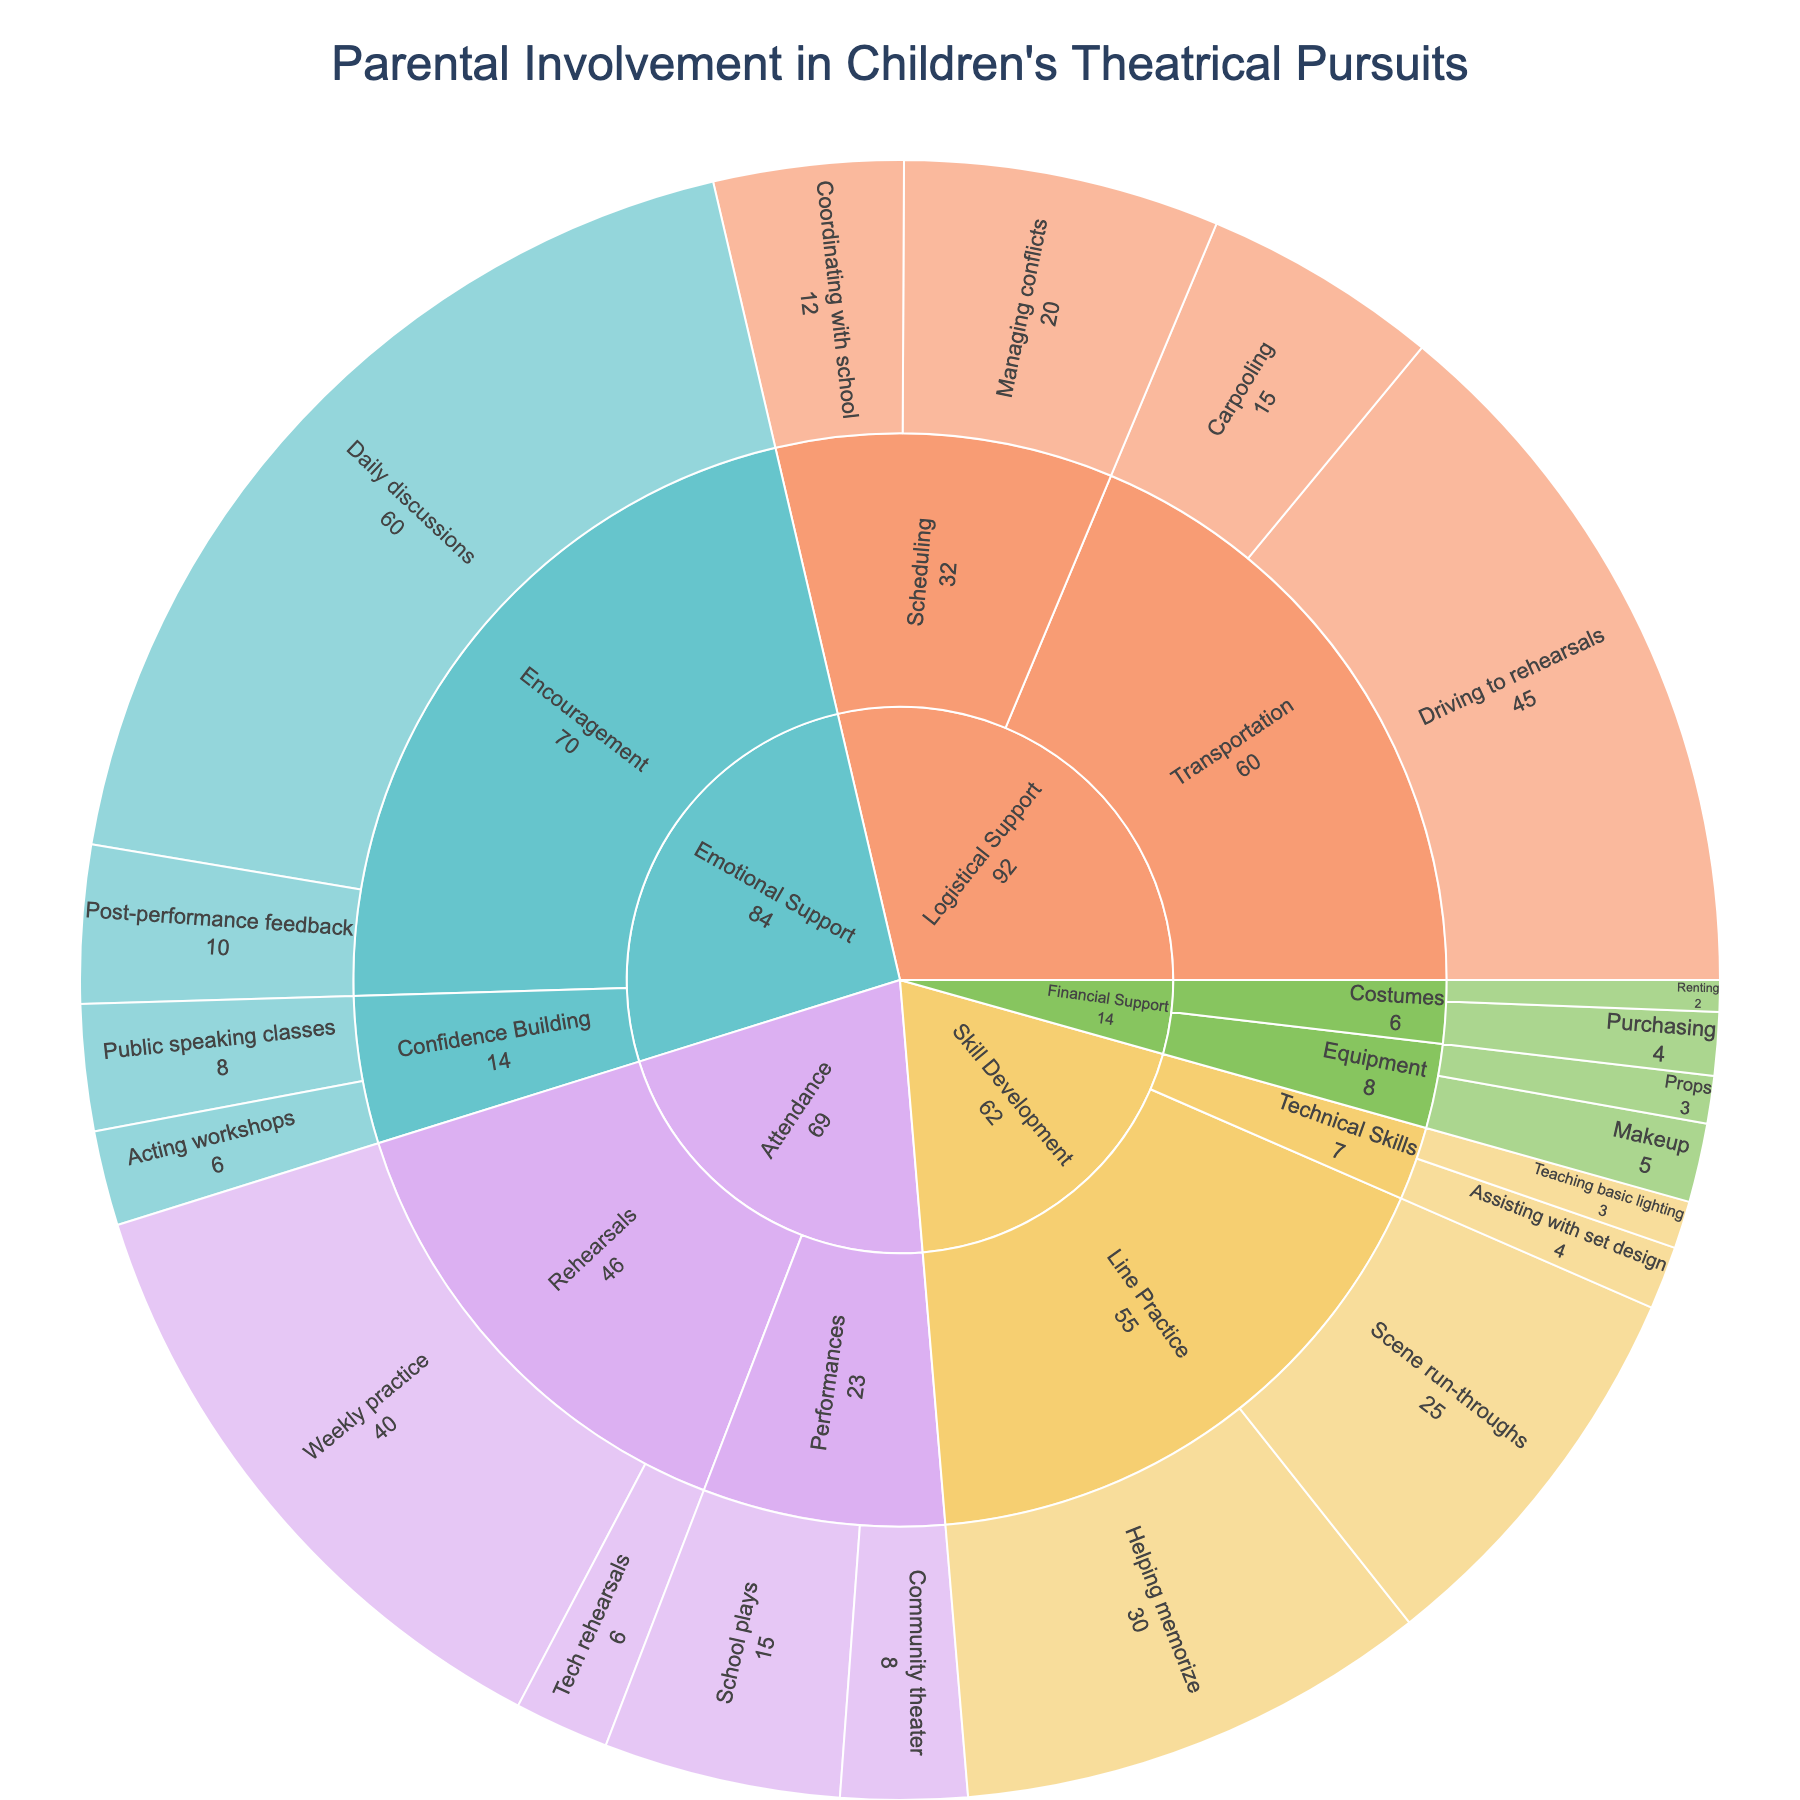What is the title of the figure? The title is typically placed at the top of the figure and provides a summary of what the plot represents. In this case, the title directly tells us about the primary focus of the plot.
Answer: Parental Involvement in Children's Theatrical Pursuits What category has the highest frequency of involvement? By looking at the largest segments in the sunburst plot, we can identify the category with the highest cumulative frequency.
Answer: Emotional Support Under Logistical Support, which subcategory has a higher frequency, Transportation or Scheduling? Locate the Logistical Support category, then compare the sizes of the segments for Transportation and Scheduling. The segment with the larger size has the higher frequency.
Answer: Transportation Which type of support is provided more frequently: Encouragement or Line Practice? First, identify the Emotional Support and Skill Development categories. Then, locate the Encouragement subcategory under Emotional Support and the Line Practice subcategory under Skill Development. Compare their segment sizes or numerical values.
Answer: Encouragement What is the total frequency for the Financial Support category? Sum the frequencies of all subcategories and types under Financial Support. This includes Costumes and Equipment with their respective types.
Answer: 14 How does the frequency of Daily discussions under Encouragement compare to Weekly practice under Rehearsals? Locate Daily discussions under Encouragement and Weekly practice under Rehearsals. Compare their frequencies.
Answer: Daily discussions has a higher frequency Which type within the Attendance category has the lowest frequency? Identify the subcategories under Attendance, then compare the frequencies of their types to determine the one with the lowest frequency.
Answer: Tech rehearsals How frequently do parents provide transportation to rehearsals? Locate the Transportation subcategory under Logistical Support and identify the frequency given for Driving to rehearsals.
Answer: 45 Calculate the total frequency of all types under Skill Development. Sum the frequencies of Helping memorize, Scene run-throughs, Assisting with set design, and Teaching basic lighting under the Skill Development category.
Answer: 62 Compare the frequencies of Purchasing and Renting costumes. Which one is higher? Locate the Costumes subcategory under Financial Support and compare the frequencies of Purchasing and Renting.
Answer: Purchasing 